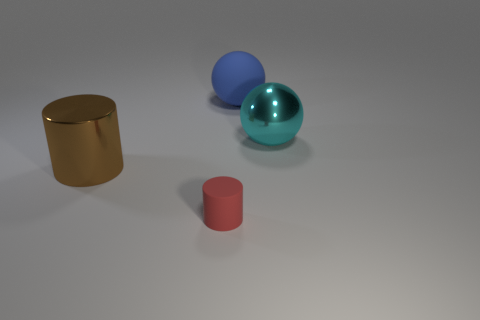If these objects were part of a game, what could be the rules? If the objects in the image were part of a game, one possible set of rules could be: Use the sphere to knock over cylinders, where the golden cylinder is worth three points and the red cylinder one point. The game could be played on turns, and each player has three tries to knock over the cylinders by rolling the sphere from a designated starting line. The winner is the person with the highest score after a set number of rounds. 